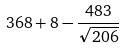Convert formula to latex. <formula><loc_0><loc_0><loc_500><loc_500>3 6 8 + 8 - \frac { 4 8 3 } { \sqrt { 2 0 6 } }</formula> 